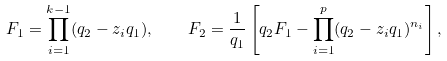Convert formula to latex. <formula><loc_0><loc_0><loc_500><loc_500>F _ { 1 } = \prod _ { i = 1 } ^ { k - 1 } ( q _ { 2 } - z _ { i } q _ { 1 } ) , \quad F _ { 2 } = \frac { 1 } { q _ { 1 } } \left [ q _ { 2 } F _ { 1 } - \prod _ { i = 1 } ^ { p } ( q _ { 2 } - z _ { i } q _ { 1 } ) ^ { n _ { i } } \right ] ,</formula> 